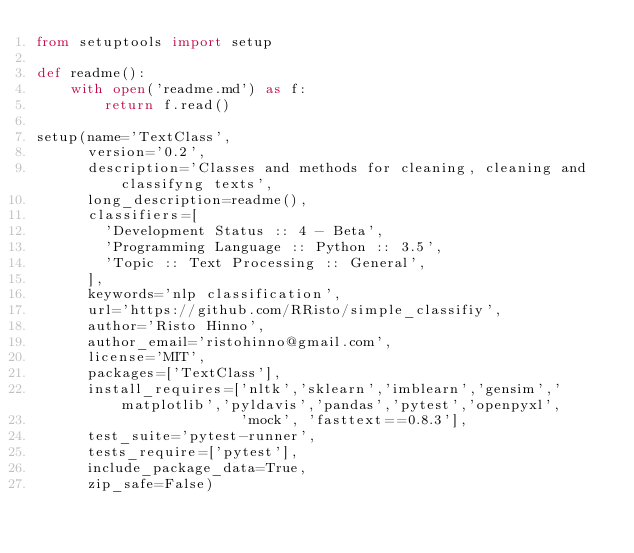Convert code to text. <code><loc_0><loc_0><loc_500><loc_500><_Python_>from setuptools import setup

def readme():
    with open('readme.md') as f:
        return f.read()

setup(name='TextClass',
      version='0.2',
      description='Classes and methods for cleaning, cleaning and classifyng texts',
      long_description=readme(),
      classifiers=[
        'Development Status :: 4 - Beta',
        'Programming Language :: Python :: 3.5',
        'Topic :: Text Processing :: General',
      ],
      keywords='nlp classification',
      url='https://github.com/RRisto/simple_classifiy',
      author='Risto Hinno',
      author_email='ristohinno@gmail.com',
      license='MIT',
      packages=['TextClass'],
      install_requires=['nltk','sklearn','imblearn','gensim','matplotlib','pyldavis','pandas','pytest','openpyxl',
                        'mock', 'fasttext==0.8.3'],
      test_suite='pytest-runner',
      tests_require=['pytest'],
      include_package_data=True,
      zip_safe=False)</code> 